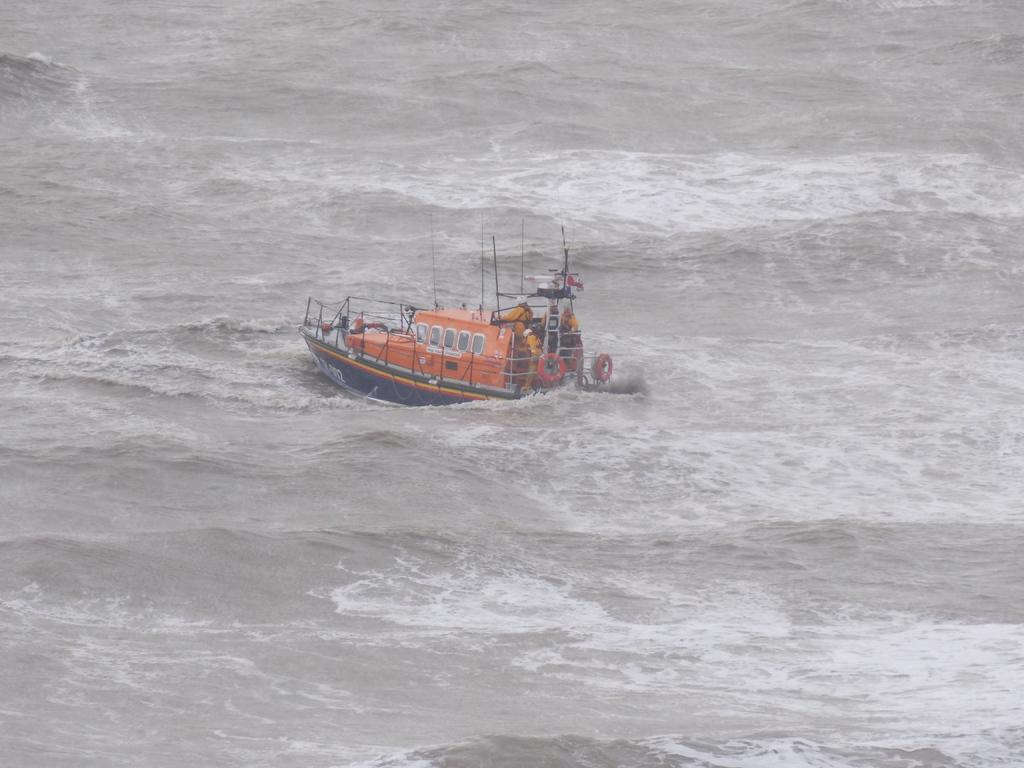What is the main subject in the center of the image? There is a ship in the center of the image. What type of environment is depicted in the image? There is water visible at the bottom of the image, suggesting a maritime setting. What type of dinner is being served on the ship in the image? There is no indication of a dinner or any food in the image; it only features a ship in a maritime setting. What flavor of brass can be seen on the ship in the image? There is no mention of brass or any specific flavor in the image; it only features a ship in a maritime setting. 